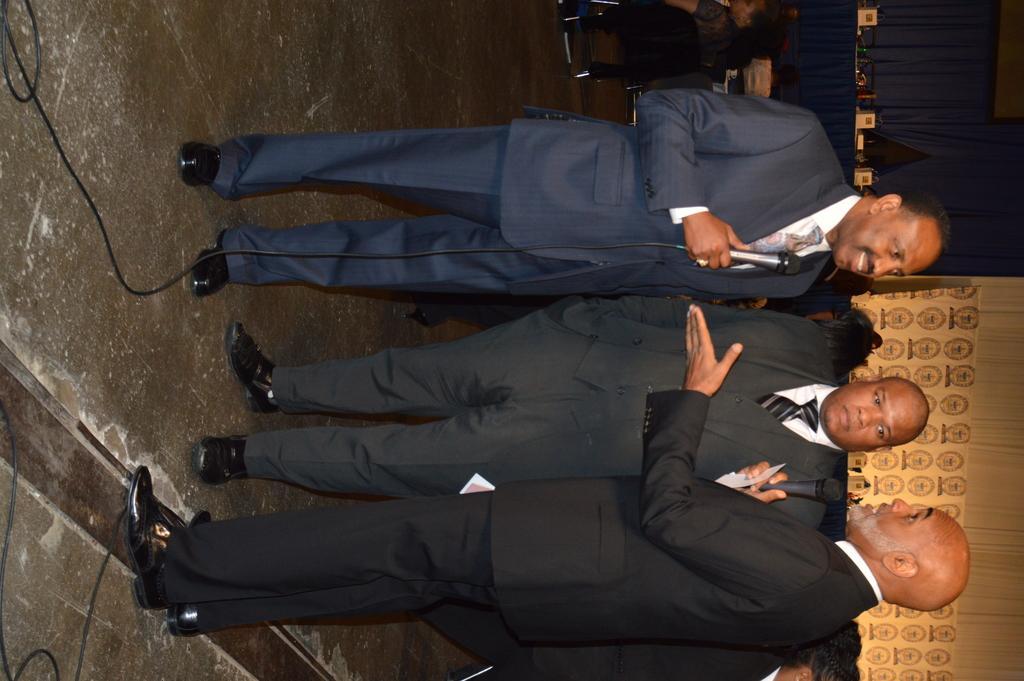Describe this image in one or two sentences. In this picture I can see few people standing. I can see couple of men holding microphones in their hands and speaking. I can see a human sitting on the chair and a board with some text in the background I can see a table and few items on it. 